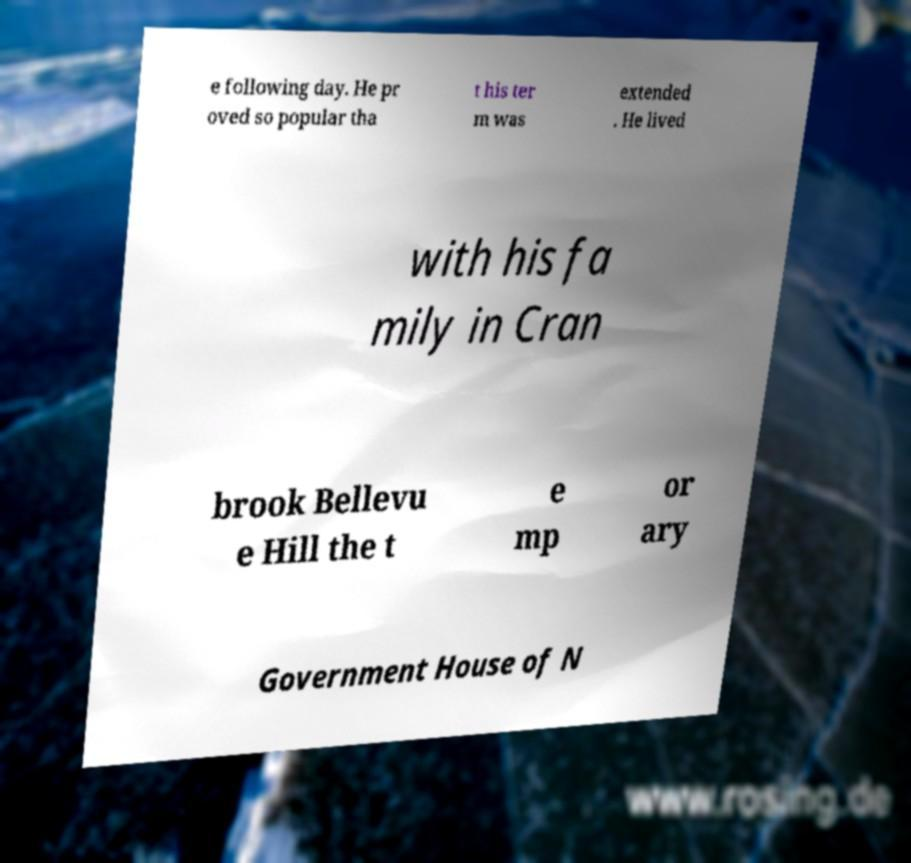Could you extract and type out the text from this image? e following day. He pr oved so popular tha t his ter m was extended . He lived with his fa mily in Cran brook Bellevu e Hill the t e mp or ary Government House of N 